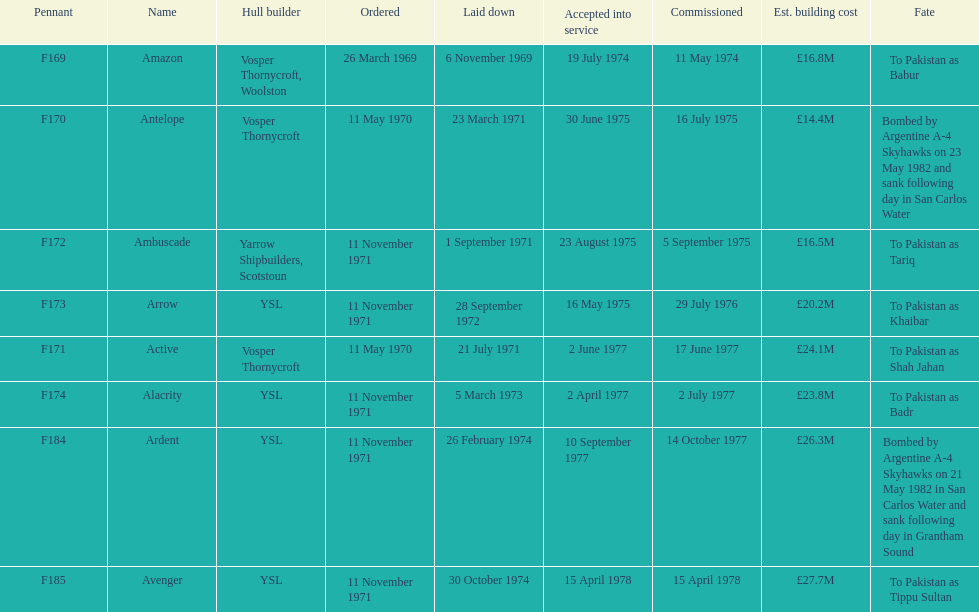Amazon is at the top of the chart, but what is the name below it? Antelope. 